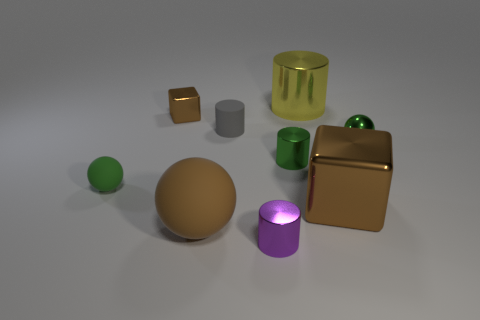Add 1 tiny green metal cylinders. How many objects exist? 10 Subtract all cylinders. How many objects are left? 5 Subtract 0 cyan cylinders. How many objects are left? 9 Subtract all small yellow metal blocks. Subtract all tiny matte balls. How many objects are left? 8 Add 6 big cylinders. How many big cylinders are left? 7 Add 5 purple things. How many purple things exist? 6 